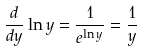Convert formula to latex. <formula><loc_0><loc_0><loc_500><loc_500>\frac { d } { d y } \ln y = \frac { 1 } { e ^ { \ln y } } = \frac { 1 } { y }</formula> 